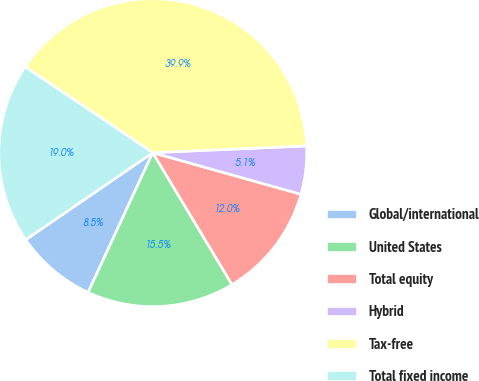Convert chart to OTSL. <chart><loc_0><loc_0><loc_500><loc_500><pie_chart><fcel>Global/international<fcel>United States<fcel>Total equity<fcel>Hybrid<fcel>Tax-free<fcel>Total fixed income<nl><fcel>8.54%<fcel>15.51%<fcel>12.03%<fcel>5.06%<fcel>39.87%<fcel>18.99%<nl></chart> 